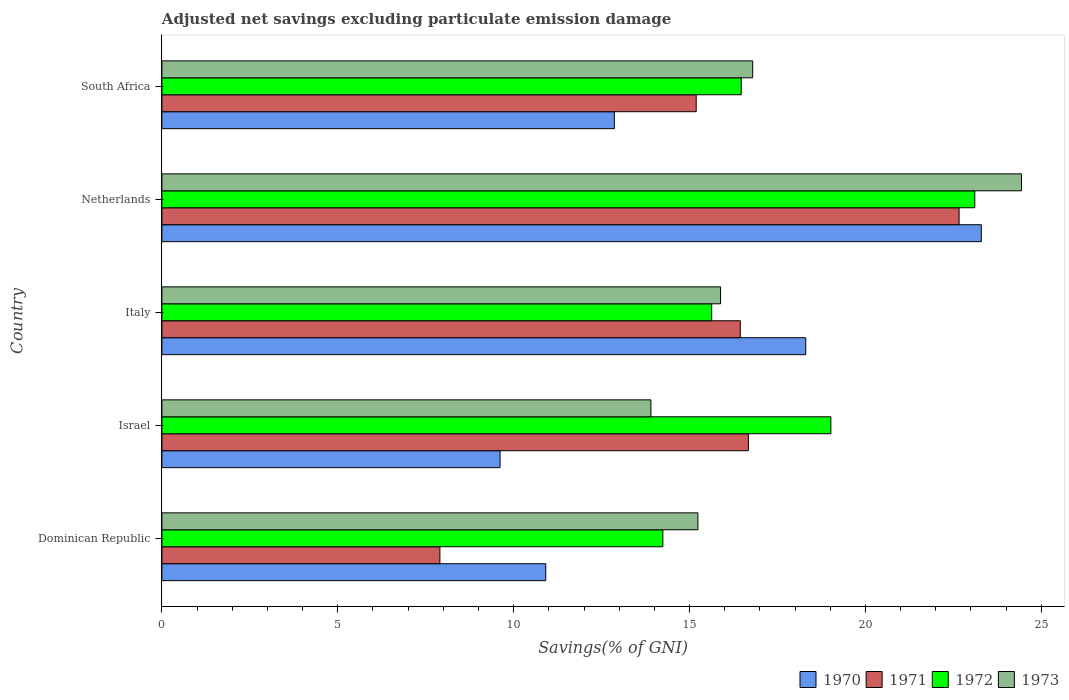Are the number of bars on each tick of the Y-axis equal?
Make the answer very short. Yes. How many bars are there on the 5th tick from the top?
Give a very brief answer. 4. How many bars are there on the 4th tick from the bottom?
Ensure brevity in your answer.  4. What is the label of the 1st group of bars from the top?
Your answer should be compact. South Africa. What is the adjusted net savings in 1972 in South Africa?
Your answer should be compact. 16.47. Across all countries, what is the maximum adjusted net savings in 1972?
Ensure brevity in your answer.  23.11. Across all countries, what is the minimum adjusted net savings in 1970?
Provide a short and direct response. 9.61. In which country was the adjusted net savings in 1971 maximum?
Offer a terse response. Netherlands. What is the total adjusted net savings in 1973 in the graph?
Provide a succinct answer. 86.26. What is the difference between the adjusted net savings in 1970 in Italy and that in Netherlands?
Offer a terse response. -4.99. What is the difference between the adjusted net savings in 1972 in Dominican Republic and the adjusted net savings in 1970 in Netherlands?
Your answer should be compact. -9.05. What is the average adjusted net savings in 1970 per country?
Offer a very short reply. 15. What is the difference between the adjusted net savings in 1973 and adjusted net savings in 1972 in South Africa?
Offer a very short reply. 0.33. What is the ratio of the adjusted net savings in 1971 in Netherlands to that in South Africa?
Offer a very short reply. 1.49. What is the difference between the highest and the second highest adjusted net savings in 1973?
Make the answer very short. 7.64. What is the difference between the highest and the lowest adjusted net savings in 1973?
Keep it short and to the point. 10.54. In how many countries, is the adjusted net savings in 1972 greater than the average adjusted net savings in 1972 taken over all countries?
Provide a short and direct response. 2. What does the 4th bar from the bottom in Israel represents?
Ensure brevity in your answer.  1973. Are all the bars in the graph horizontal?
Offer a very short reply. Yes. Where does the legend appear in the graph?
Your response must be concise. Bottom right. How are the legend labels stacked?
Make the answer very short. Horizontal. What is the title of the graph?
Make the answer very short. Adjusted net savings excluding particulate emission damage. What is the label or title of the X-axis?
Ensure brevity in your answer.  Savings(% of GNI). What is the label or title of the Y-axis?
Give a very brief answer. Country. What is the Savings(% of GNI) of 1970 in Dominican Republic?
Provide a succinct answer. 10.91. What is the Savings(% of GNI) in 1971 in Dominican Republic?
Make the answer very short. 7.9. What is the Savings(% of GNI) in 1972 in Dominican Republic?
Provide a succinct answer. 14.24. What is the Savings(% of GNI) in 1973 in Dominican Republic?
Keep it short and to the point. 15.24. What is the Savings(% of GNI) of 1970 in Israel?
Your response must be concise. 9.61. What is the Savings(% of GNI) of 1971 in Israel?
Keep it short and to the point. 16.67. What is the Savings(% of GNI) of 1972 in Israel?
Your answer should be very brief. 19.02. What is the Savings(% of GNI) in 1973 in Israel?
Your answer should be compact. 13.9. What is the Savings(% of GNI) in 1970 in Italy?
Offer a very short reply. 18.3. What is the Savings(% of GNI) in 1971 in Italy?
Your answer should be compact. 16.44. What is the Savings(% of GNI) in 1972 in Italy?
Offer a terse response. 15.63. What is the Savings(% of GNI) in 1973 in Italy?
Provide a short and direct response. 15.88. What is the Savings(% of GNI) in 1970 in Netherlands?
Make the answer very short. 23.3. What is the Savings(% of GNI) in 1971 in Netherlands?
Your answer should be very brief. 22.66. What is the Savings(% of GNI) in 1972 in Netherlands?
Your answer should be compact. 23.11. What is the Savings(% of GNI) of 1973 in Netherlands?
Ensure brevity in your answer.  24.44. What is the Savings(% of GNI) of 1970 in South Africa?
Your answer should be compact. 12.86. What is the Savings(% of GNI) of 1971 in South Africa?
Make the answer very short. 15.19. What is the Savings(% of GNI) of 1972 in South Africa?
Offer a terse response. 16.47. What is the Savings(% of GNI) of 1973 in South Africa?
Your answer should be very brief. 16.8. Across all countries, what is the maximum Savings(% of GNI) of 1970?
Offer a terse response. 23.3. Across all countries, what is the maximum Savings(% of GNI) of 1971?
Give a very brief answer. 22.66. Across all countries, what is the maximum Savings(% of GNI) in 1972?
Keep it short and to the point. 23.11. Across all countries, what is the maximum Savings(% of GNI) in 1973?
Your response must be concise. 24.44. Across all countries, what is the minimum Savings(% of GNI) in 1970?
Offer a very short reply. 9.61. Across all countries, what is the minimum Savings(% of GNI) of 1971?
Offer a terse response. 7.9. Across all countries, what is the minimum Savings(% of GNI) of 1972?
Provide a short and direct response. 14.24. Across all countries, what is the minimum Savings(% of GNI) of 1973?
Offer a terse response. 13.9. What is the total Savings(% of GNI) in 1970 in the graph?
Your answer should be compact. 74.99. What is the total Savings(% of GNI) of 1971 in the graph?
Your answer should be very brief. 78.88. What is the total Savings(% of GNI) of 1972 in the graph?
Keep it short and to the point. 88.47. What is the total Savings(% of GNI) in 1973 in the graph?
Keep it short and to the point. 86.26. What is the difference between the Savings(% of GNI) of 1970 in Dominican Republic and that in Israel?
Your answer should be compact. 1.3. What is the difference between the Savings(% of GNI) in 1971 in Dominican Republic and that in Israel?
Provide a succinct answer. -8.77. What is the difference between the Savings(% of GNI) in 1972 in Dominican Republic and that in Israel?
Provide a short and direct response. -4.78. What is the difference between the Savings(% of GNI) of 1973 in Dominican Republic and that in Israel?
Your response must be concise. 1.34. What is the difference between the Savings(% of GNI) of 1970 in Dominican Republic and that in Italy?
Keep it short and to the point. -7.39. What is the difference between the Savings(% of GNI) of 1971 in Dominican Republic and that in Italy?
Provide a short and direct response. -8.54. What is the difference between the Savings(% of GNI) in 1972 in Dominican Republic and that in Italy?
Your response must be concise. -1.39. What is the difference between the Savings(% of GNI) in 1973 in Dominican Republic and that in Italy?
Offer a terse response. -0.65. What is the difference between the Savings(% of GNI) of 1970 in Dominican Republic and that in Netherlands?
Your answer should be very brief. -12.38. What is the difference between the Savings(% of GNI) of 1971 in Dominican Republic and that in Netherlands?
Offer a terse response. -14.76. What is the difference between the Savings(% of GNI) of 1972 in Dominican Republic and that in Netherlands?
Offer a terse response. -8.87. What is the difference between the Savings(% of GNI) of 1973 in Dominican Republic and that in Netherlands?
Give a very brief answer. -9.2. What is the difference between the Savings(% of GNI) of 1970 in Dominican Republic and that in South Africa?
Give a very brief answer. -1.95. What is the difference between the Savings(% of GNI) in 1971 in Dominican Republic and that in South Africa?
Provide a succinct answer. -7.29. What is the difference between the Savings(% of GNI) of 1972 in Dominican Republic and that in South Africa?
Give a very brief answer. -2.23. What is the difference between the Savings(% of GNI) in 1973 in Dominican Republic and that in South Africa?
Give a very brief answer. -1.56. What is the difference between the Savings(% of GNI) in 1970 in Israel and that in Italy?
Keep it short and to the point. -8.69. What is the difference between the Savings(% of GNI) in 1971 in Israel and that in Italy?
Provide a short and direct response. 0.23. What is the difference between the Savings(% of GNI) of 1972 in Israel and that in Italy?
Offer a terse response. 3.39. What is the difference between the Savings(% of GNI) in 1973 in Israel and that in Italy?
Make the answer very short. -1.98. What is the difference between the Savings(% of GNI) in 1970 in Israel and that in Netherlands?
Your answer should be compact. -13.68. What is the difference between the Savings(% of GNI) of 1971 in Israel and that in Netherlands?
Your response must be concise. -5.99. What is the difference between the Savings(% of GNI) in 1972 in Israel and that in Netherlands?
Provide a succinct answer. -4.09. What is the difference between the Savings(% of GNI) in 1973 in Israel and that in Netherlands?
Provide a short and direct response. -10.54. What is the difference between the Savings(% of GNI) in 1970 in Israel and that in South Africa?
Your response must be concise. -3.25. What is the difference between the Savings(% of GNI) of 1971 in Israel and that in South Africa?
Ensure brevity in your answer.  1.48. What is the difference between the Savings(% of GNI) of 1972 in Israel and that in South Africa?
Offer a terse response. 2.55. What is the difference between the Savings(% of GNI) in 1973 in Israel and that in South Africa?
Make the answer very short. -2.89. What is the difference between the Savings(% of GNI) of 1970 in Italy and that in Netherlands?
Offer a terse response. -4.99. What is the difference between the Savings(% of GNI) of 1971 in Italy and that in Netherlands?
Give a very brief answer. -6.22. What is the difference between the Savings(% of GNI) in 1972 in Italy and that in Netherlands?
Give a very brief answer. -7.48. What is the difference between the Savings(% of GNI) in 1973 in Italy and that in Netherlands?
Provide a succinct answer. -8.56. What is the difference between the Savings(% of GNI) of 1970 in Italy and that in South Africa?
Your answer should be compact. 5.44. What is the difference between the Savings(% of GNI) in 1971 in Italy and that in South Africa?
Keep it short and to the point. 1.25. What is the difference between the Savings(% of GNI) of 1972 in Italy and that in South Africa?
Make the answer very short. -0.84. What is the difference between the Savings(% of GNI) in 1973 in Italy and that in South Africa?
Your answer should be very brief. -0.91. What is the difference between the Savings(% of GNI) in 1970 in Netherlands and that in South Africa?
Make the answer very short. 10.43. What is the difference between the Savings(% of GNI) in 1971 in Netherlands and that in South Africa?
Your response must be concise. 7.47. What is the difference between the Savings(% of GNI) in 1972 in Netherlands and that in South Africa?
Provide a short and direct response. 6.64. What is the difference between the Savings(% of GNI) of 1973 in Netherlands and that in South Africa?
Keep it short and to the point. 7.64. What is the difference between the Savings(% of GNI) in 1970 in Dominican Republic and the Savings(% of GNI) in 1971 in Israel?
Your response must be concise. -5.76. What is the difference between the Savings(% of GNI) in 1970 in Dominican Republic and the Savings(% of GNI) in 1972 in Israel?
Offer a very short reply. -8.11. What is the difference between the Savings(% of GNI) of 1970 in Dominican Republic and the Savings(% of GNI) of 1973 in Israel?
Offer a very short reply. -2.99. What is the difference between the Savings(% of GNI) of 1971 in Dominican Republic and the Savings(% of GNI) of 1972 in Israel?
Offer a very short reply. -11.11. What is the difference between the Savings(% of GNI) of 1971 in Dominican Republic and the Savings(% of GNI) of 1973 in Israel?
Your answer should be compact. -6. What is the difference between the Savings(% of GNI) of 1972 in Dominican Republic and the Savings(% of GNI) of 1973 in Israel?
Your answer should be very brief. 0.34. What is the difference between the Savings(% of GNI) of 1970 in Dominican Republic and the Savings(% of GNI) of 1971 in Italy?
Ensure brevity in your answer.  -5.53. What is the difference between the Savings(% of GNI) of 1970 in Dominican Republic and the Savings(% of GNI) of 1972 in Italy?
Your answer should be compact. -4.72. What is the difference between the Savings(% of GNI) of 1970 in Dominican Republic and the Savings(% of GNI) of 1973 in Italy?
Keep it short and to the point. -4.97. What is the difference between the Savings(% of GNI) in 1971 in Dominican Republic and the Savings(% of GNI) in 1972 in Italy?
Your answer should be compact. -7.73. What is the difference between the Savings(% of GNI) in 1971 in Dominican Republic and the Savings(% of GNI) in 1973 in Italy?
Offer a very short reply. -7.98. What is the difference between the Savings(% of GNI) in 1972 in Dominican Republic and the Savings(% of GNI) in 1973 in Italy?
Make the answer very short. -1.64. What is the difference between the Savings(% of GNI) in 1970 in Dominican Republic and the Savings(% of GNI) in 1971 in Netherlands?
Provide a succinct answer. -11.75. What is the difference between the Savings(% of GNI) of 1970 in Dominican Republic and the Savings(% of GNI) of 1972 in Netherlands?
Your answer should be very brief. -12.2. What is the difference between the Savings(% of GNI) in 1970 in Dominican Republic and the Savings(% of GNI) in 1973 in Netherlands?
Provide a short and direct response. -13.53. What is the difference between the Savings(% of GNI) of 1971 in Dominican Republic and the Savings(% of GNI) of 1972 in Netherlands?
Ensure brevity in your answer.  -15.21. What is the difference between the Savings(% of GNI) of 1971 in Dominican Republic and the Savings(% of GNI) of 1973 in Netherlands?
Your answer should be compact. -16.53. What is the difference between the Savings(% of GNI) in 1972 in Dominican Republic and the Savings(% of GNI) in 1973 in Netherlands?
Provide a succinct answer. -10.2. What is the difference between the Savings(% of GNI) of 1970 in Dominican Republic and the Savings(% of GNI) of 1971 in South Africa?
Offer a very short reply. -4.28. What is the difference between the Savings(% of GNI) in 1970 in Dominican Republic and the Savings(% of GNI) in 1972 in South Africa?
Give a very brief answer. -5.56. What is the difference between the Savings(% of GNI) in 1970 in Dominican Republic and the Savings(% of GNI) in 1973 in South Africa?
Offer a terse response. -5.88. What is the difference between the Savings(% of GNI) of 1971 in Dominican Republic and the Savings(% of GNI) of 1972 in South Africa?
Your answer should be very brief. -8.57. What is the difference between the Savings(% of GNI) in 1971 in Dominican Republic and the Savings(% of GNI) in 1973 in South Africa?
Offer a terse response. -8.89. What is the difference between the Savings(% of GNI) in 1972 in Dominican Republic and the Savings(% of GNI) in 1973 in South Africa?
Give a very brief answer. -2.55. What is the difference between the Savings(% of GNI) in 1970 in Israel and the Savings(% of GNI) in 1971 in Italy?
Your answer should be very brief. -6.83. What is the difference between the Savings(% of GNI) in 1970 in Israel and the Savings(% of GNI) in 1972 in Italy?
Your answer should be compact. -6.02. What is the difference between the Savings(% of GNI) of 1970 in Israel and the Savings(% of GNI) of 1973 in Italy?
Make the answer very short. -6.27. What is the difference between the Savings(% of GNI) of 1971 in Israel and the Savings(% of GNI) of 1972 in Italy?
Provide a succinct answer. 1.04. What is the difference between the Savings(% of GNI) of 1971 in Israel and the Savings(% of GNI) of 1973 in Italy?
Your answer should be very brief. 0.79. What is the difference between the Savings(% of GNI) in 1972 in Israel and the Savings(% of GNI) in 1973 in Italy?
Provide a succinct answer. 3.14. What is the difference between the Savings(% of GNI) of 1970 in Israel and the Savings(% of GNI) of 1971 in Netherlands?
Offer a terse response. -13.05. What is the difference between the Savings(% of GNI) in 1970 in Israel and the Savings(% of GNI) in 1972 in Netherlands?
Offer a very short reply. -13.49. What is the difference between the Savings(% of GNI) in 1970 in Israel and the Savings(% of GNI) in 1973 in Netherlands?
Your answer should be very brief. -14.82. What is the difference between the Savings(% of GNI) of 1971 in Israel and the Savings(% of GNI) of 1972 in Netherlands?
Give a very brief answer. -6.44. What is the difference between the Savings(% of GNI) in 1971 in Israel and the Savings(% of GNI) in 1973 in Netherlands?
Your response must be concise. -7.76. What is the difference between the Savings(% of GNI) of 1972 in Israel and the Savings(% of GNI) of 1973 in Netherlands?
Offer a terse response. -5.42. What is the difference between the Savings(% of GNI) in 1970 in Israel and the Savings(% of GNI) in 1971 in South Africa?
Provide a short and direct response. -5.58. What is the difference between the Savings(% of GNI) of 1970 in Israel and the Savings(% of GNI) of 1972 in South Africa?
Provide a succinct answer. -6.86. What is the difference between the Savings(% of GNI) of 1970 in Israel and the Savings(% of GNI) of 1973 in South Africa?
Provide a succinct answer. -7.18. What is the difference between the Savings(% of GNI) of 1971 in Israel and the Savings(% of GNI) of 1972 in South Africa?
Give a very brief answer. 0.2. What is the difference between the Savings(% of GNI) in 1971 in Israel and the Savings(% of GNI) in 1973 in South Africa?
Your answer should be very brief. -0.12. What is the difference between the Savings(% of GNI) of 1972 in Israel and the Savings(% of GNI) of 1973 in South Africa?
Give a very brief answer. 2.22. What is the difference between the Savings(% of GNI) in 1970 in Italy and the Savings(% of GNI) in 1971 in Netherlands?
Make the answer very short. -4.36. What is the difference between the Savings(% of GNI) in 1970 in Italy and the Savings(% of GNI) in 1972 in Netherlands?
Offer a very short reply. -4.81. What is the difference between the Savings(% of GNI) of 1970 in Italy and the Savings(% of GNI) of 1973 in Netherlands?
Ensure brevity in your answer.  -6.13. What is the difference between the Savings(% of GNI) in 1971 in Italy and the Savings(% of GNI) in 1972 in Netherlands?
Offer a very short reply. -6.67. What is the difference between the Savings(% of GNI) in 1971 in Italy and the Savings(% of GNI) in 1973 in Netherlands?
Your answer should be very brief. -7.99. What is the difference between the Savings(% of GNI) of 1972 in Italy and the Savings(% of GNI) of 1973 in Netherlands?
Offer a very short reply. -8.81. What is the difference between the Savings(% of GNI) of 1970 in Italy and the Savings(% of GNI) of 1971 in South Africa?
Provide a short and direct response. 3.11. What is the difference between the Savings(% of GNI) in 1970 in Italy and the Savings(% of GNI) in 1972 in South Africa?
Give a very brief answer. 1.83. What is the difference between the Savings(% of GNI) in 1970 in Italy and the Savings(% of GNI) in 1973 in South Africa?
Your answer should be compact. 1.51. What is the difference between the Savings(% of GNI) in 1971 in Italy and the Savings(% of GNI) in 1972 in South Africa?
Your answer should be compact. -0.03. What is the difference between the Savings(% of GNI) of 1971 in Italy and the Savings(% of GNI) of 1973 in South Africa?
Ensure brevity in your answer.  -0.35. What is the difference between the Savings(% of GNI) in 1972 in Italy and the Savings(% of GNI) in 1973 in South Africa?
Make the answer very short. -1.17. What is the difference between the Savings(% of GNI) in 1970 in Netherlands and the Savings(% of GNI) in 1971 in South Africa?
Your response must be concise. 8.11. What is the difference between the Savings(% of GNI) of 1970 in Netherlands and the Savings(% of GNI) of 1972 in South Africa?
Make the answer very short. 6.83. What is the difference between the Savings(% of GNI) in 1970 in Netherlands and the Savings(% of GNI) in 1973 in South Africa?
Your answer should be very brief. 6.5. What is the difference between the Savings(% of GNI) of 1971 in Netherlands and the Savings(% of GNI) of 1972 in South Africa?
Your answer should be very brief. 6.19. What is the difference between the Savings(% of GNI) of 1971 in Netherlands and the Savings(% of GNI) of 1973 in South Africa?
Provide a succinct answer. 5.87. What is the difference between the Savings(% of GNI) in 1972 in Netherlands and the Savings(% of GNI) in 1973 in South Africa?
Offer a very short reply. 6.31. What is the average Savings(% of GNI) in 1970 per country?
Your answer should be compact. 15. What is the average Savings(% of GNI) of 1971 per country?
Your answer should be very brief. 15.78. What is the average Savings(% of GNI) of 1972 per country?
Offer a very short reply. 17.69. What is the average Savings(% of GNI) in 1973 per country?
Offer a terse response. 17.25. What is the difference between the Savings(% of GNI) of 1970 and Savings(% of GNI) of 1971 in Dominican Republic?
Provide a succinct answer. 3.01. What is the difference between the Savings(% of GNI) in 1970 and Savings(% of GNI) in 1972 in Dominican Republic?
Keep it short and to the point. -3.33. What is the difference between the Savings(% of GNI) in 1970 and Savings(% of GNI) in 1973 in Dominican Republic?
Your answer should be very brief. -4.33. What is the difference between the Savings(% of GNI) of 1971 and Savings(% of GNI) of 1972 in Dominican Republic?
Your answer should be very brief. -6.34. What is the difference between the Savings(% of GNI) of 1971 and Savings(% of GNI) of 1973 in Dominican Republic?
Offer a very short reply. -7.33. What is the difference between the Savings(% of GNI) in 1972 and Savings(% of GNI) in 1973 in Dominican Republic?
Ensure brevity in your answer.  -1. What is the difference between the Savings(% of GNI) of 1970 and Savings(% of GNI) of 1971 in Israel?
Provide a short and direct response. -7.06. What is the difference between the Savings(% of GNI) in 1970 and Savings(% of GNI) in 1972 in Israel?
Give a very brief answer. -9.4. What is the difference between the Savings(% of GNI) in 1970 and Savings(% of GNI) in 1973 in Israel?
Keep it short and to the point. -4.29. What is the difference between the Savings(% of GNI) of 1971 and Savings(% of GNI) of 1972 in Israel?
Ensure brevity in your answer.  -2.34. What is the difference between the Savings(% of GNI) of 1971 and Savings(% of GNI) of 1973 in Israel?
Your answer should be compact. 2.77. What is the difference between the Savings(% of GNI) in 1972 and Savings(% of GNI) in 1973 in Israel?
Your answer should be compact. 5.12. What is the difference between the Savings(% of GNI) in 1970 and Savings(% of GNI) in 1971 in Italy?
Provide a succinct answer. 1.86. What is the difference between the Savings(% of GNI) in 1970 and Savings(% of GNI) in 1972 in Italy?
Your answer should be very brief. 2.67. What is the difference between the Savings(% of GNI) of 1970 and Savings(% of GNI) of 1973 in Italy?
Keep it short and to the point. 2.42. What is the difference between the Savings(% of GNI) in 1971 and Savings(% of GNI) in 1972 in Italy?
Provide a succinct answer. 0.81. What is the difference between the Savings(% of GNI) in 1971 and Savings(% of GNI) in 1973 in Italy?
Keep it short and to the point. 0.56. What is the difference between the Savings(% of GNI) of 1972 and Savings(% of GNI) of 1973 in Italy?
Your answer should be compact. -0.25. What is the difference between the Savings(% of GNI) in 1970 and Savings(% of GNI) in 1971 in Netherlands?
Provide a succinct answer. 0.63. What is the difference between the Savings(% of GNI) in 1970 and Savings(% of GNI) in 1972 in Netherlands?
Make the answer very short. 0.19. What is the difference between the Savings(% of GNI) in 1970 and Savings(% of GNI) in 1973 in Netherlands?
Offer a terse response. -1.14. What is the difference between the Savings(% of GNI) of 1971 and Savings(% of GNI) of 1972 in Netherlands?
Keep it short and to the point. -0.45. What is the difference between the Savings(% of GNI) of 1971 and Savings(% of GNI) of 1973 in Netherlands?
Make the answer very short. -1.77. What is the difference between the Savings(% of GNI) in 1972 and Savings(% of GNI) in 1973 in Netherlands?
Your answer should be very brief. -1.33. What is the difference between the Savings(% of GNI) of 1970 and Savings(% of GNI) of 1971 in South Africa?
Provide a short and direct response. -2.33. What is the difference between the Savings(% of GNI) of 1970 and Savings(% of GNI) of 1972 in South Africa?
Ensure brevity in your answer.  -3.61. What is the difference between the Savings(% of GNI) in 1970 and Savings(% of GNI) in 1973 in South Africa?
Make the answer very short. -3.93. What is the difference between the Savings(% of GNI) of 1971 and Savings(% of GNI) of 1972 in South Africa?
Your answer should be very brief. -1.28. What is the difference between the Savings(% of GNI) in 1971 and Savings(% of GNI) in 1973 in South Africa?
Your answer should be compact. -1.61. What is the difference between the Savings(% of GNI) in 1972 and Savings(% of GNI) in 1973 in South Africa?
Your answer should be compact. -0.33. What is the ratio of the Savings(% of GNI) of 1970 in Dominican Republic to that in Israel?
Keep it short and to the point. 1.14. What is the ratio of the Savings(% of GNI) of 1971 in Dominican Republic to that in Israel?
Your answer should be compact. 0.47. What is the ratio of the Savings(% of GNI) in 1972 in Dominican Republic to that in Israel?
Provide a succinct answer. 0.75. What is the ratio of the Savings(% of GNI) in 1973 in Dominican Republic to that in Israel?
Keep it short and to the point. 1.1. What is the ratio of the Savings(% of GNI) of 1970 in Dominican Republic to that in Italy?
Make the answer very short. 0.6. What is the ratio of the Savings(% of GNI) in 1971 in Dominican Republic to that in Italy?
Your answer should be compact. 0.48. What is the ratio of the Savings(% of GNI) in 1972 in Dominican Republic to that in Italy?
Ensure brevity in your answer.  0.91. What is the ratio of the Savings(% of GNI) of 1973 in Dominican Republic to that in Italy?
Keep it short and to the point. 0.96. What is the ratio of the Savings(% of GNI) in 1970 in Dominican Republic to that in Netherlands?
Your answer should be compact. 0.47. What is the ratio of the Savings(% of GNI) in 1971 in Dominican Republic to that in Netherlands?
Ensure brevity in your answer.  0.35. What is the ratio of the Savings(% of GNI) of 1972 in Dominican Republic to that in Netherlands?
Offer a very short reply. 0.62. What is the ratio of the Savings(% of GNI) of 1973 in Dominican Republic to that in Netherlands?
Make the answer very short. 0.62. What is the ratio of the Savings(% of GNI) in 1970 in Dominican Republic to that in South Africa?
Your answer should be compact. 0.85. What is the ratio of the Savings(% of GNI) in 1971 in Dominican Republic to that in South Africa?
Make the answer very short. 0.52. What is the ratio of the Savings(% of GNI) of 1972 in Dominican Republic to that in South Africa?
Make the answer very short. 0.86. What is the ratio of the Savings(% of GNI) of 1973 in Dominican Republic to that in South Africa?
Your answer should be very brief. 0.91. What is the ratio of the Savings(% of GNI) in 1970 in Israel to that in Italy?
Your response must be concise. 0.53. What is the ratio of the Savings(% of GNI) of 1972 in Israel to that in Italy?
Ensure brevity in your answer.  1.22. What is the ratio of the Savings(% of GNI) in 1973 in Israel to that in Italy?
Keep it short and to the point. 0.88. What is the ratio of the Savings(% of GNI) of 1970 in Israel to that in Netherlands?
Your answer should be very brief. 0.41. What is the ratio of the Savings(% of GNI) of 1971 in Israel to that in Netherlands?
Keep it short and to the point. 0.74. What is the ratio of the Savings(% of GNI) of 1972 in Israel to that in Netherlands?
Offer a very short reply. 0.82. What is the ratio of the Savings(% of GNI) of 1973 in Israel to that in Netherlands?
Ensure brevity in your answer.  0.57. What is the ratio of the Savings(% of GNI) in 1970 in Israel to that in South Africa?
Your answer should be very brief. 0.75. What is the ratio of the Savings(% of GNI) of 1971 in Israel to that in South Africa?
Ensure brevity in your answer.  1.1. What is the ratio of the Savings(% of GNI) in 1972 in Israel to that in South Africa?
Offer a very short reply. 1.15. What is the ratio of the Savings(% of GNI) in 1973 in Israel to that in South Africa?
Provide a short and direct response. 0.83. What is the ratio of the Savings(% of GNI) of 1970 in Italy to that in Netherlands?
Your response must be concise. 0.79. What is the ratio of the Savings(% of GNI) of 1971 in Italy to that in Netherlands?
Offer a terse response. 0.73. What is the ratio of the Savings(% of GNI) in 1972 in Italy to that in Netherlands?
Give a very brief answer. 0.68. What is the ratio of the Savings(% of GNI) in 1973 in Italy to that in Netherlands?
Give a very brief answer. 0.65. What is the ratio of the Savings(% of GNI) in 1970 in Italy to that in South Africa?
Provide a short and direct response. 1.42. What is the ratio of the Savings(% of GNI) of 1971 in Italy to that in South Africa?
Make the answer very short. 1.08. What is the ratio of the Savings(% of GNI) in 1972 in Italy to that in South Africa?
Provide a succinct answer. 0.95. What is the ratio of the Savings(% of GNI) of 1973 in Italy to that in South Africa?
Offer a very short reply. 0.95. What is the ratio of the Savings(% of GNI) in 1970 in Netherlands to that in South Africa?
Provide a succinct answer. 1.81. What is the ratio of the Savings(% of GNI) in 1971 in Netherlands to that in South Africa?
Your answer should be compact. 1.49. What is the ratio of the Savings(% of GNI) in 1972 in Netherlands to that in South Africa?
Your answer should be compact. 1.4. What is the ratio of the Savings(% of GNI) of 1973 in Netherlands to that in South Africa?
Ensure brevity in your answer.  1.46. What is the difference between the highest and the second highest Savings(% of GNI) of 1970?
Make the answer very short. 4.99. What is the difference between the highest and the second highest Savings(% of GNI) in 1971?
Offer a very short reply. 5.99. What is the difference between the highest and the second highest Savings(% of GNI) in 1972?
Give a very brief answer. 4.09. What is the difference between the highest and the second highest Savings(% of GNI) in 1973?
Your answer should be compact. 7.64. What is the difference between the highest and the lowest Savings(% of GNI) of 1970?
Your response must be concise. 13.68. What is the difference between the highest and the lowest Savings(% of GNI) of 1971?
Your answer should be very brief. 14.76. What is the difference between the highest and the lowest Savings(% of GNI) in 1972?
Give a very brief answer. 8.87. What is the difference between the highest and the lowest Savings(% of GNI) of 1973?
Provide a short and direct response. 10.54. 